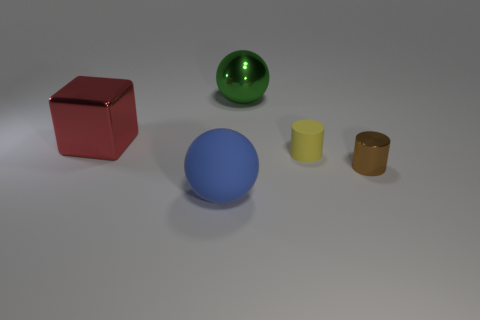There is a matte object that is behind the shiny thing that is to the right of the tiny yellow thing; what shape is it?
Give a very brief answer. Cylinder. Is there anything else that is the same color as the small metal thing?
Offer a very short reply. No. The big thing to the left of the big blue rubber ball has what shape?
Provide a succinct answer. Cube. The large object that is both in front of the large green metallic sphere and behind the large matte thing has what shape?
Offer a terse response. Cube. How many red things are either big matte objects or large shiny blocks?
Make the answer very short. 1. There is a matte thing that is in front of the brown cylinder; does it have the same color as the tiny metal cylinder?
Make the answer very short. No. How big is the thing that is in front of the shiny cylinder that is behind the large rubber thing?
Your answer should be compact. Large. What material is the other yellow cylinder that is the same size as the metallic cylinder?
Make the answer very short. Rubber. What number of other objects are the same size as the metal cylinder?
Offer a very short reply. 1. How many balls are big things or big red metal objects?
Give a very brief answer. 2. 